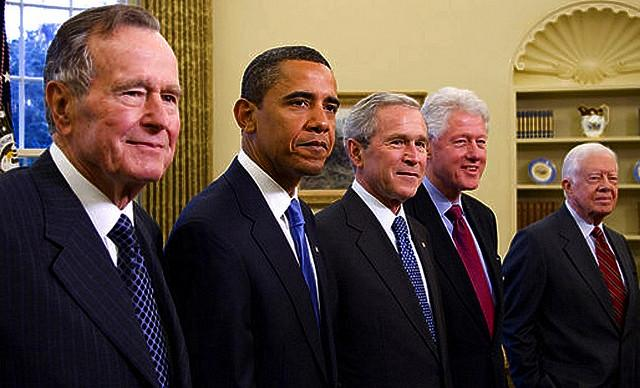What do these men have in common?

Choices:
A) chess players
B) sports team
C) presidency
D) corporate ownership presidency 